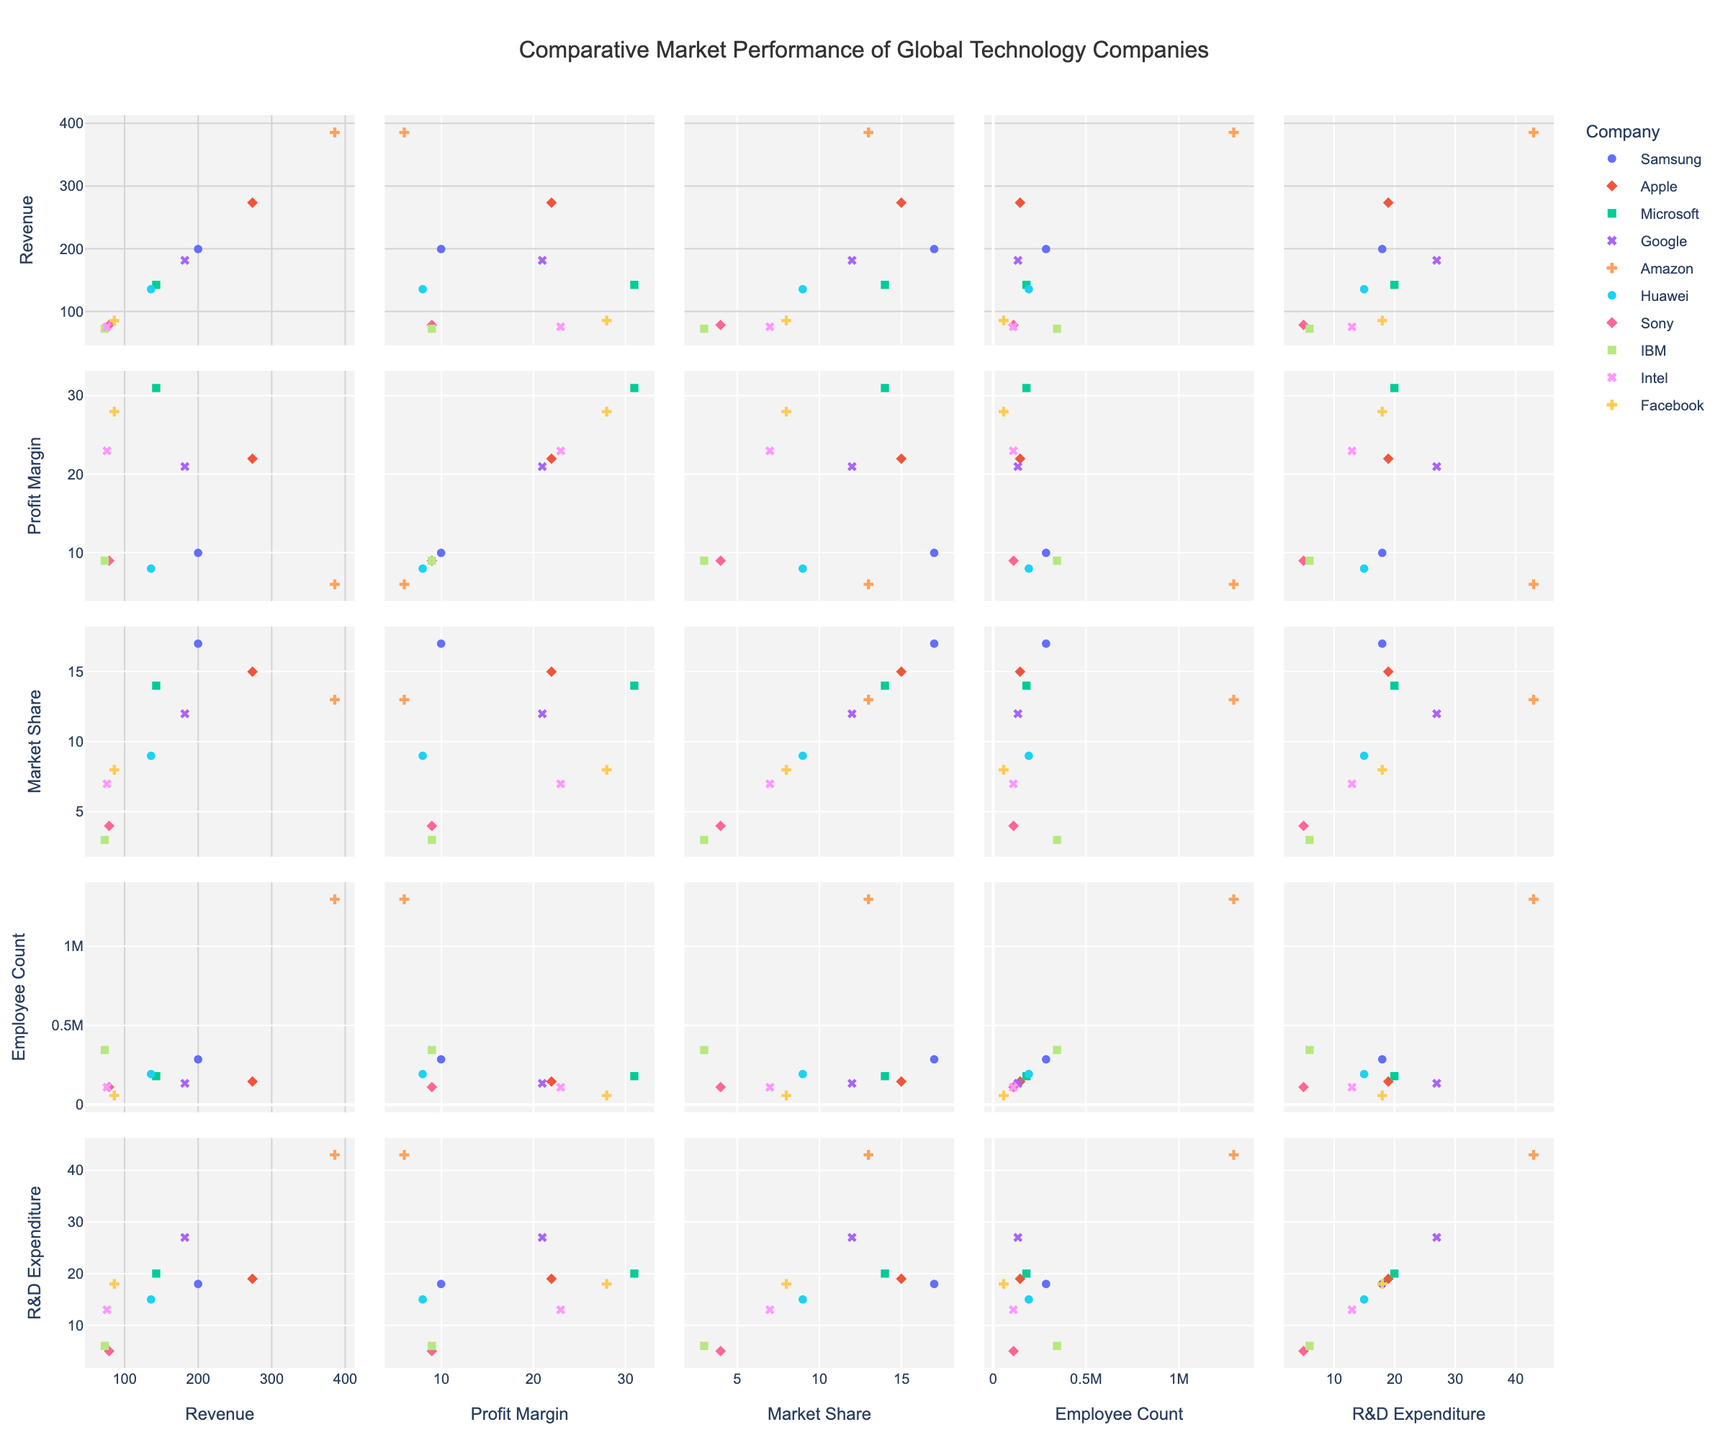How many companies are represented in the figure? The figure uses color and symbol indicators to differentiate each company. By counting the unique symbols/colors in the legend, you can determine the number of companies. In this case, there are 10 companies listed: Samsung, Apple, Microsoft, Google, Amazon, Huawei, Sony, IBM, Intel, and Facebook.
Answer: 10 Which company has the highest R&D expenditure? By locating the R&D Expenditure (Billion USD) axis, we can find the data point that reaches the highest value. According to the dataset, Amazon has the highest expenditure at 43 billion USD.
Answer: Amazon Compare the market share percentage of Samsung and Apple. To compare the Market Share (%), locate the data points for Samsung and Apple on the Market Share (%) axis. Samsung's market share is 17%, whereas Apple's is 15%. Thus, Samsung’s market share is higher than Apple’s.
Answer: Samsung What is the general relationship between Revenue and Employee Count? To understand the relationship, review the scatter plot matrix section that compares Revenue (Billion USD) and Employee Count. It appears that companies with higher revenue tend to have a higher employee count, indicating a positive correlation.
Answer: Positive correlation Which company has the least number of employees, and how does its market share compare to other companies with high employee counts? Locate the Employee Count axis and find the smallest value. The company with the least number of employees is Facebook with 58,604 employees. When comparing market share, Facebook has an 8% share, which is close to or comparable with some companies that have higher employee counts, like Huawei (9%) and IBM (3%).
Answer: Facebook; comparable to Huawei and IBM Which companies fall above a 20% profit margin? Reviewing the data points along the Profit Margin (%) axis, companies that fall above the 20% mark are Apple (22%), Microsoft (31%), Google (21%), Facebook (28%), and Intel (23%).
Answer: Apple, Microsoft, Google, Facebook, Intel What can be inferred about the relationship between R&D Expenditure and Profit Margin from this data? By examining the scatter plots relating R&D Expenditure (Billion USD) to Profit Margin (%), there does not appear to be a straightforward correlation. Some companies with high R&D expenditure like Amazon have a low-profit margin (6%), while others like Microsoft have lower R&D but higher profit margins (31%).
Answer: No straightforward correlation Is there any company with a high number of employees but low revenue? By locating Employee Count and Revenue (Billion USD), IBM stands out as having a significantly high number of employees (345,900) but relatively low revenue (73 billion USD) compared to other high-employee counterparts.
Answer: IBM 